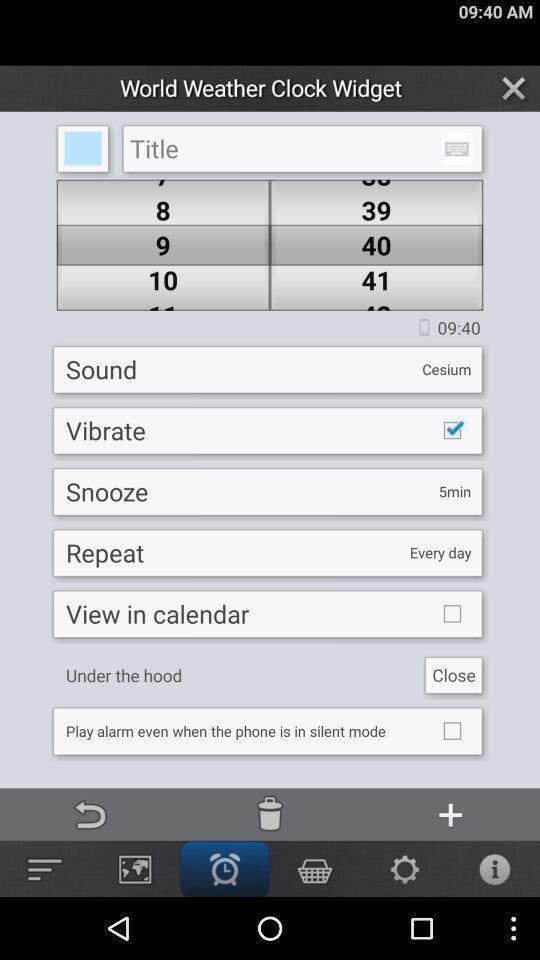Give me a narrative description of this picture. Screen displaying multiple setting options in a weather application. 